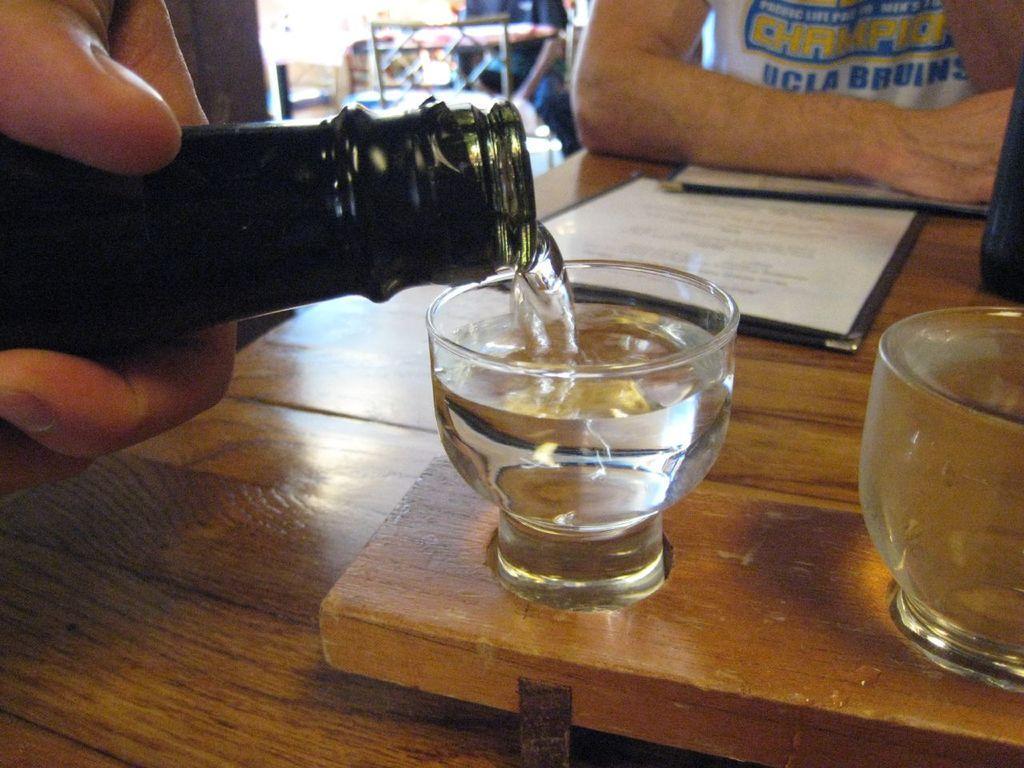Please provide a concise description of this image. In this picture, we see the hand of the person holding a glass bottle. He is pouring the liquid into the glass. Beside that, we see an empty glass. These glasses and a file or a certificate is placed on the wooden table. At the top, we see a man in white T-shirt is sitting on the chair. Beside him, we see a man is standing and beside that, we see a stand. 